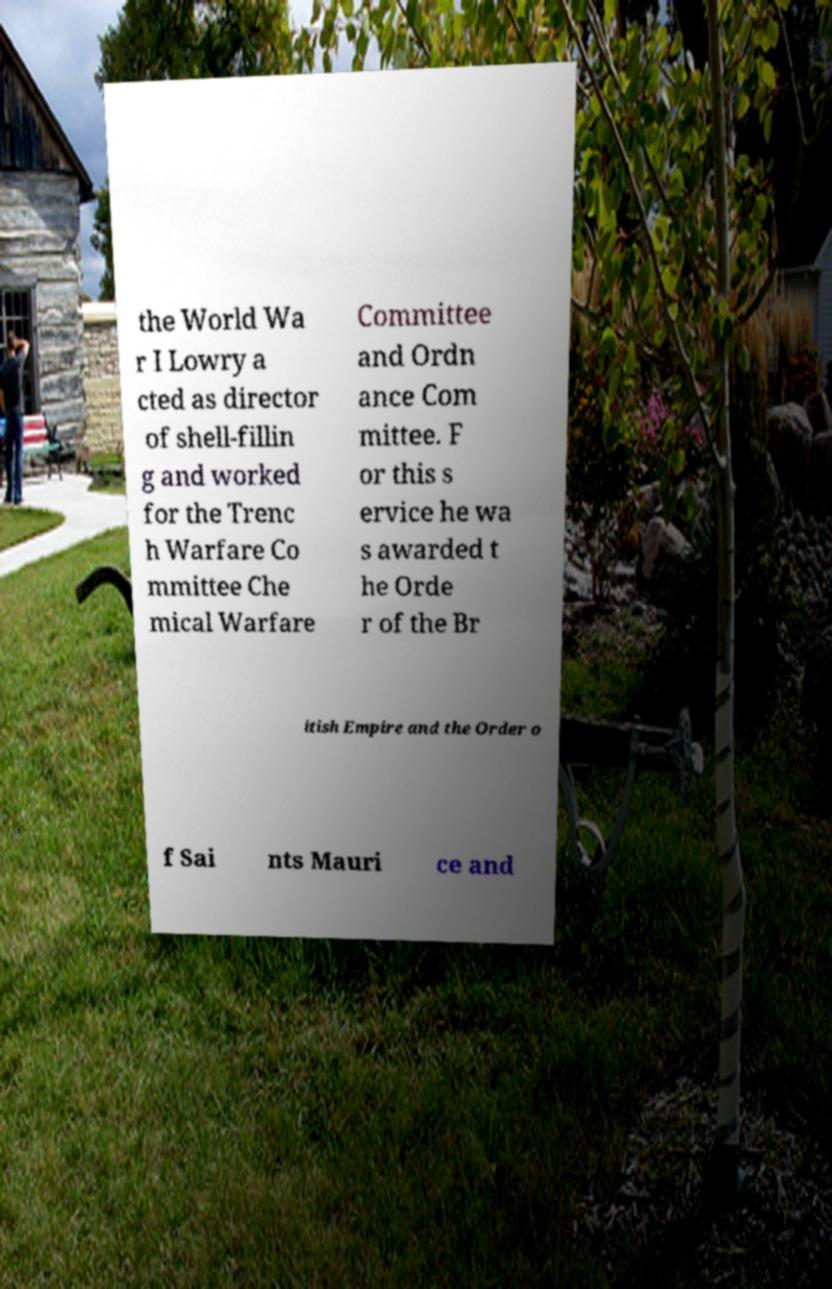What messages or text are displayed in this image? I need them in a readable, typed format. the World Wa r I Lowry a cted as director of shell-fillin g and worked for the Trenc h Warfare Co mmittee Che mical Warfare Committee and Ordn ance Com mittee. F or this s ervice he wa s awarded t he Orde r of the Br itish Empire and the Order o f Sai nts Mauri ce and 